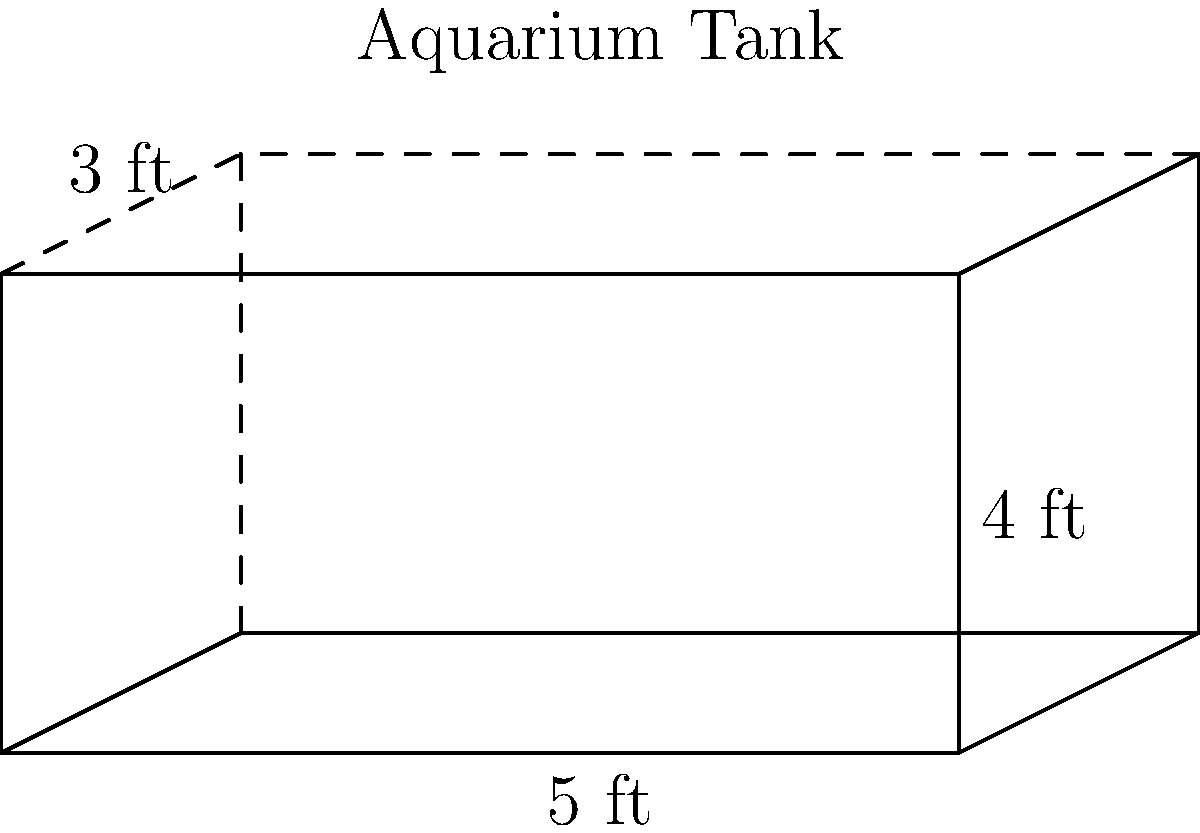As a turtle enthusiast who has visited Ripley's Aquariums, you're familiar with various tank sizes. Given the aquarium tank dimensions shown in the diagram, estimate its volume in cubic feet. Round your answer to the nearest whole number. To calculate the volume of a rectangular aquarium tank, we use the formula:

$$V = l \times w \times h$$

Where:
$V$ = volume
$l$ = length
$w$ = width
$h$ = height

From the diagram, we can see:
Length ($l$) = 5 ft
Width ($w$) = 3 ft
Height ($h$) = 4 ft

Plugging these values into our formula:

$$V = 5 \text{ ft} \times 3 \text{ ft} \times 4 \text{ ft}$$
$$V = 60 \text{ cubic feet}$$

Since the question asks to round to the nearest whole number, our final answer is 60 cubic feet.

This volume is equivalent to approximately 448 gallons, which is a medium-sized tank suitable for various turtle species, depending on their size and number.
Answer: 60 cubic feet 